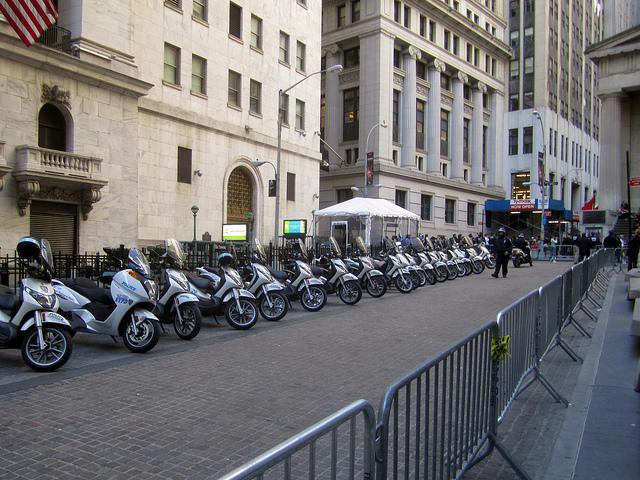Where the woman be walking too?
Short answer required. Work. What mode of transportation is parked at the fence?
Concise answer only. Motorcycle. How many bikes can be seen?
Write a very short answer. 18. Is this a city or countryside?
Write a very short answer. City. What kind of vehicle is shown?
Concise answer only. Motorcycle. 